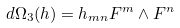Convert formula to latex. <formula><loc_0><loc_0><loc_500><loc_500>d \Omega _ { 3 } ( h ) = h _ { m n } F ^ { m } \wedge F ^ { n }</formula> 